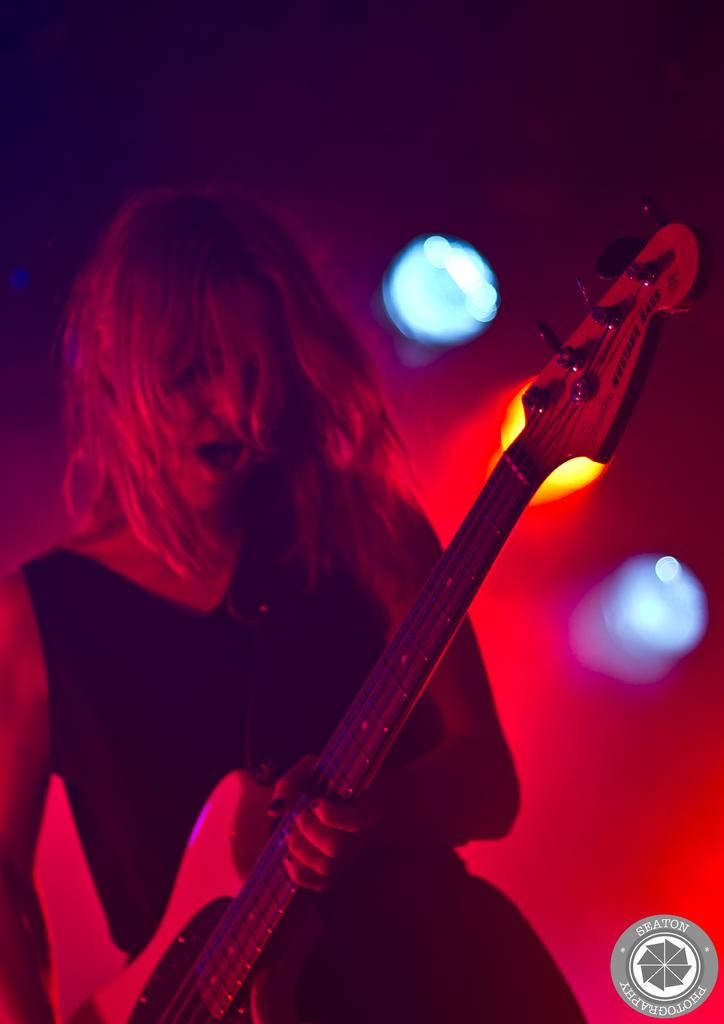What is the person in the image holding? The person is holding a guitar in the image. What is the person wearing? The person is wearing a black dress. What can be seen in the background of the image? There are lights in the background of the image. What colors are the lights? The lights have orange and blue colors. Can you tell me how the person is using their memory to play the guitar in the image? There is no indication in the image that the person is using their memory to play the guitar; they may be playing by ear, reading sheet music, or using other methods. 